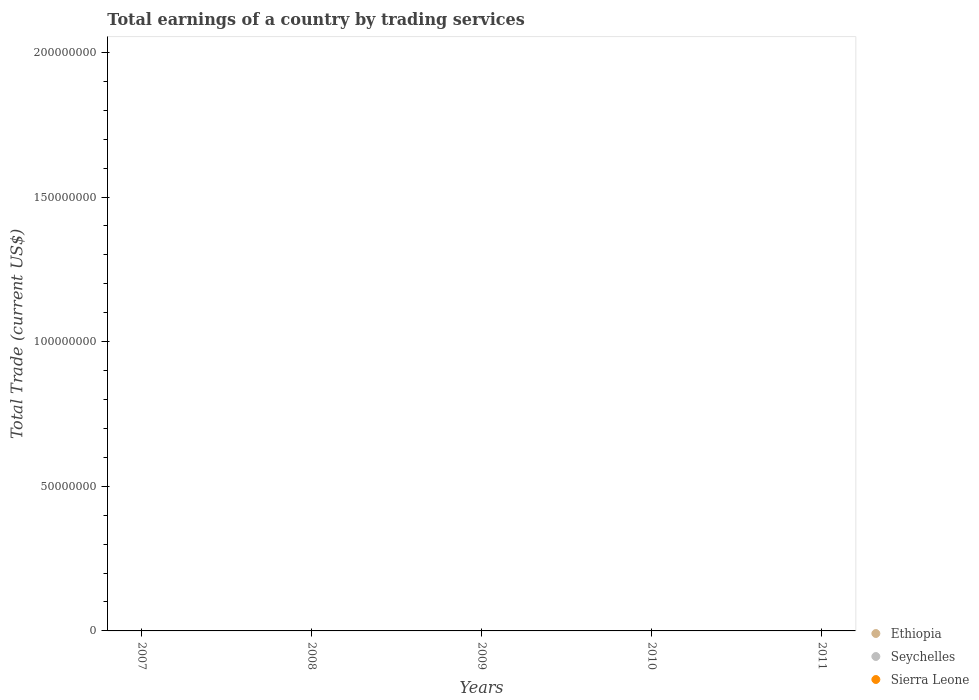Is the number of dotlines equal to the number of legend labels?
Keep it short and to the point. No. What is the total earnings in Ethiopia in 2008?
Your answer should be very brief. 0. Across all years, what is the minimum total earnings in Ethiopia?
Offer a very short reply. 0. What is the difference between the total earnings in Sierra Leone in 2008 and the total earnings in Ethiopia in 2010?
Your answer should be very brief. 0. In how many years, is the total earnings in Sierra Leone greater than the average total earnings in Sierra Leone taken over all years?
Offer a very short reply. 0. Does the total earnings in Sierra Leone monotonically increase over the years?
Your answer should be very brief. No. Is the total earnings in Seychelles strictly greater than the total earnings in Ethiopia over the years?
Your answer should be compact. Yes. Is the total earnings in Ethiopia strictly less than the total earnings in Seychelles over the years?
Ensure brevity in your answer.  Yes. Does the graph contain any zero values?
Offer a very short reply. Yes. Where does the legend appear in the graph?
Make the answer very short. Bottom right. What is the title of the graph?
Provide a short and direct response. Total earnings of a country by trading services. Does "Niger" appear as one of the legend labels in the graph?
Ensure brevity in your answer.  No. What is the label or title of the X-axis?
Make the answer very short. Years. What is the label or title of the Y-axis?
Your answer should be very brief. Total Trade (current US$). What is the Total Trade (current US$) in Ethiopia in 2007?
Keep it short and to the point. 0. What is the Total Trade (current US$) in Seychelles in 2007?
Offer a very short reply. 0. What is the Total Trade (current US$) of Seychelles in 2009?
Your response must be concise. 0. What is the Total Trade (current US$) of Ethiopia in 2010?
Your answer should be very brief. 0. What is the Total Trade (current US$) of Sierra Leone in 2010?
Provide a succinct answer. 0. What is the total Total Trade (current US$) of Ethiopia in the graph?
Offer a terse response. 0. What is the total Total Trade (current US$) of Seychelles in the graph?
Offer a very short reply. 0. What is the total Total Trade (current US$) in Sierra Leone in the graph?
Offer a terse response. 0. What is the average Total Trade (current US$) of Sierra Leone per year?
Keep it short and to the point. 0. 